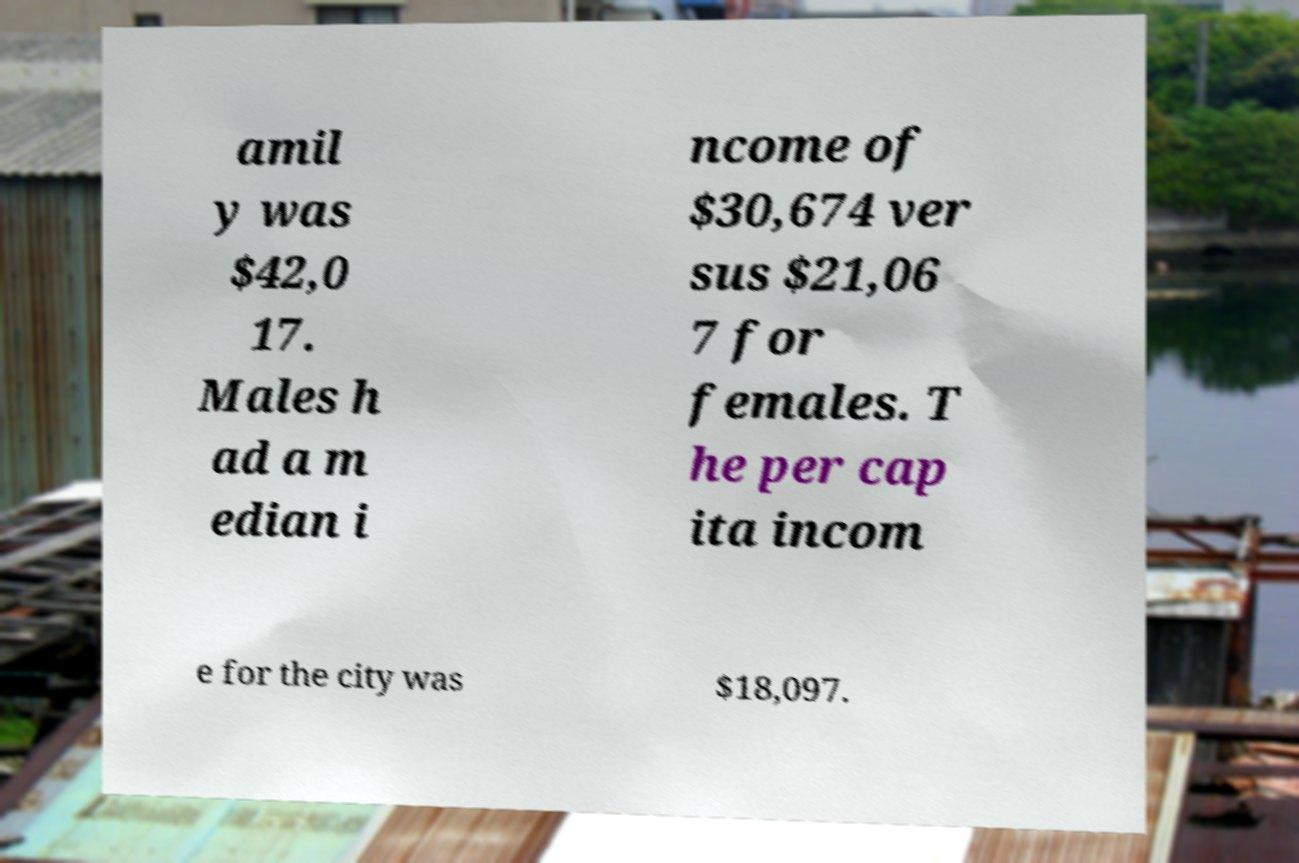Could you extract and type out the text from this image? amil y was $42,0 17. Males h ad a m edian i ncome of $30,674 ver sus $21,06 7 for females. T he per cap ita incom e for the city was $18,097. 